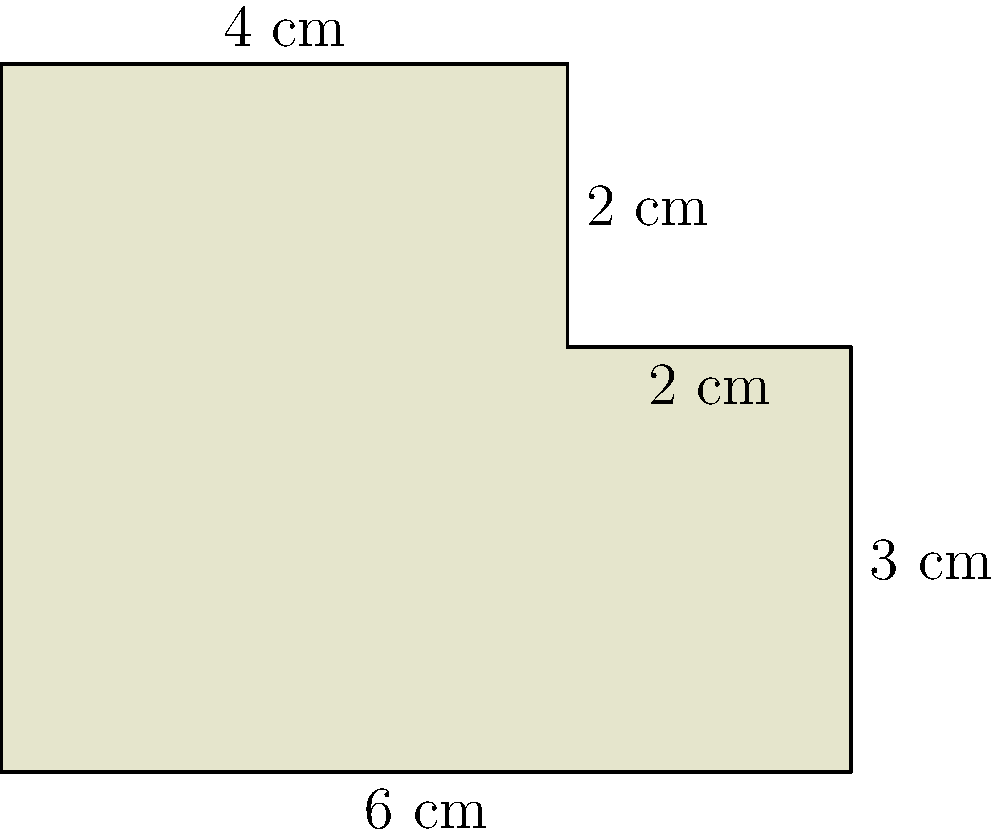As a local painter in Sunderland, you've created a unique irregularly shaped canvas for your next masterpiece. The canvas is composed of a rectangle with a smaller rectangle attached to its top right corner, as shown in the diagram. Calculate the total area of this canvas in square centimeters. To calculate the area of this irregularly shaped canvas, we can break it down into two rectangles and add their areas:

1. Large rectangle:
   Width = 6 cm
   Height = 3 cm
   Area of large rectangle = $6 \times 3 = 18$ cm²

2. Small rectangle:
   Width = 2 cm
   Height = 2 cm
   Area of small rectangle = $2 \times 2 = 4$ cm²

3. Total area:
   Total area = Area of large rectangle + Area of small rectangle
               = $18 + 4 = 22$ cm²

Therefore, the total area of the irregularly shaped canvas is 22 square centimeters.
Answer: 22 cm² 